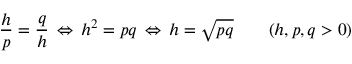<formula> <loc_0><loc_0><loc_500><loc_500>{ \frac { h } { p } } = { \frac { q } { h } } \, \Leftrightarrow \, h ^ { 2 } = p q \, \Leftrightarrow \, h = { \sqrt { p q } } \quad ( h , p , q > 0 )</formula> 